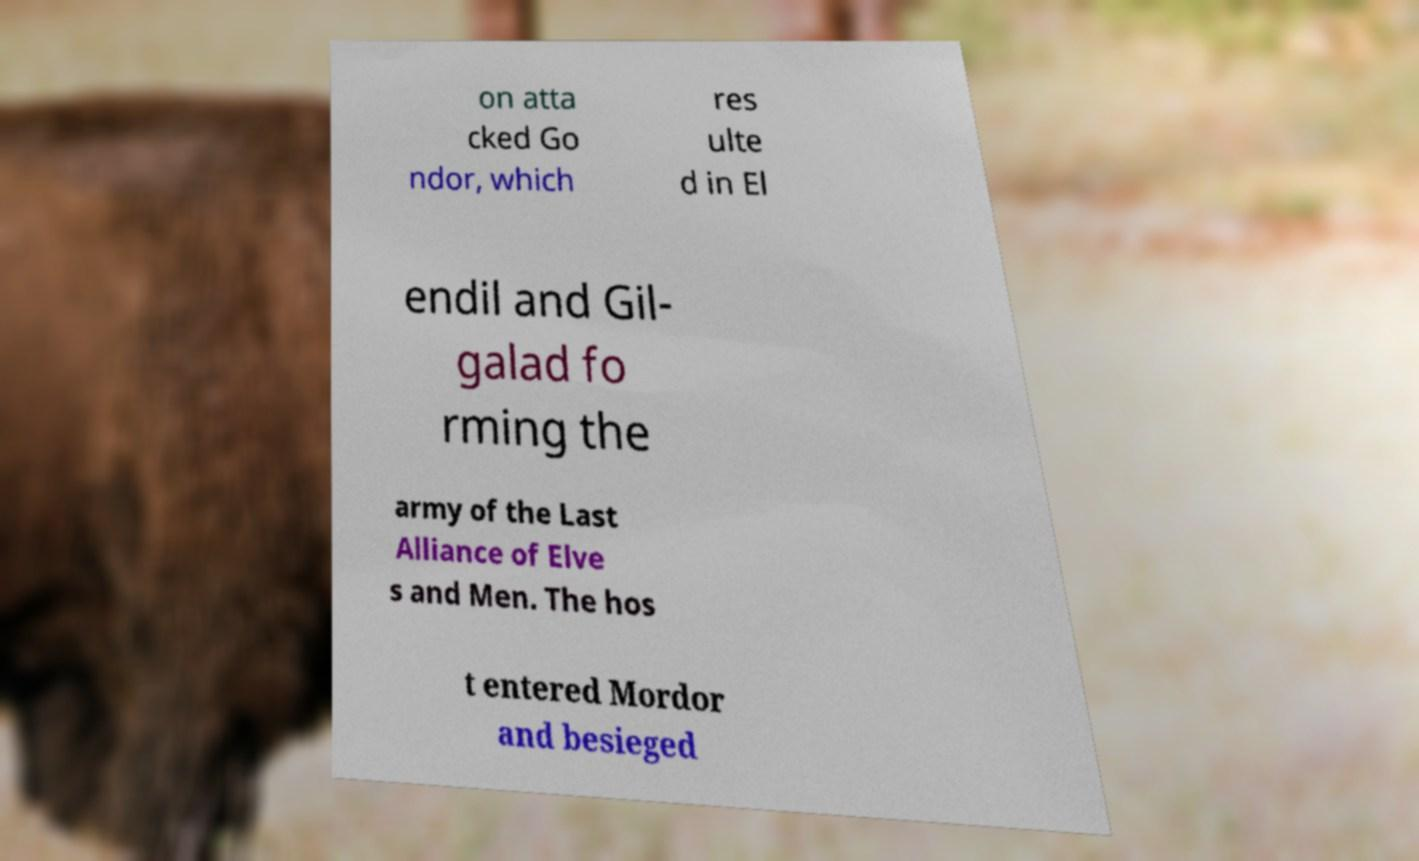For documentation purposes, I need the text within this image transcribed. Could you provide that? on atta cked Go ndor, which res ulte d in El endil and Gil- galad fo rming the army of the Last Alliance of Elve s and Men. The hos t entered Mordor and besieged 